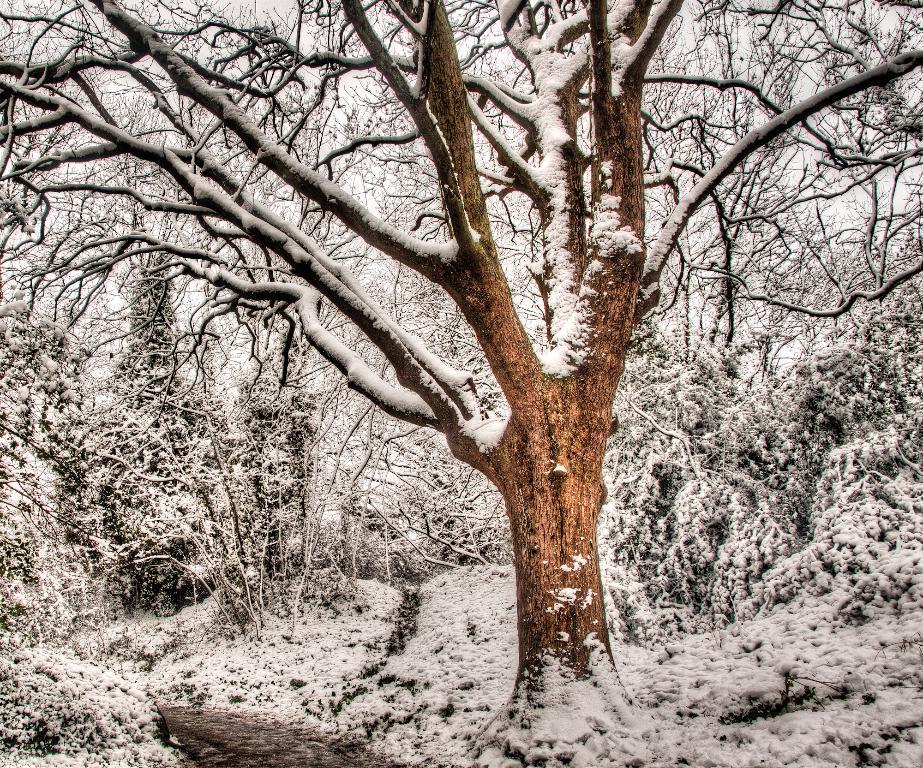Can you describe this image briefly? In this image we can see a group of trees and a bark of a tree which are covered with the snow. On the backside we can see the sky. 